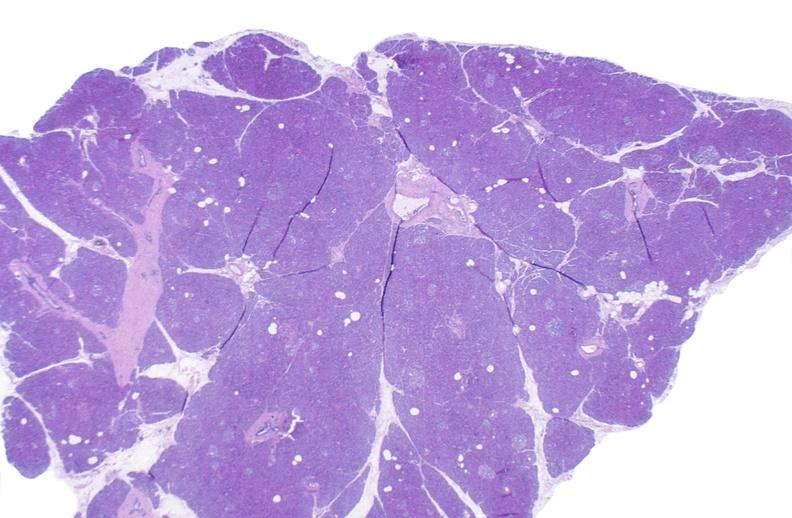what does this image show?
Answer the question using a single word or phrase. Normal pancreas 